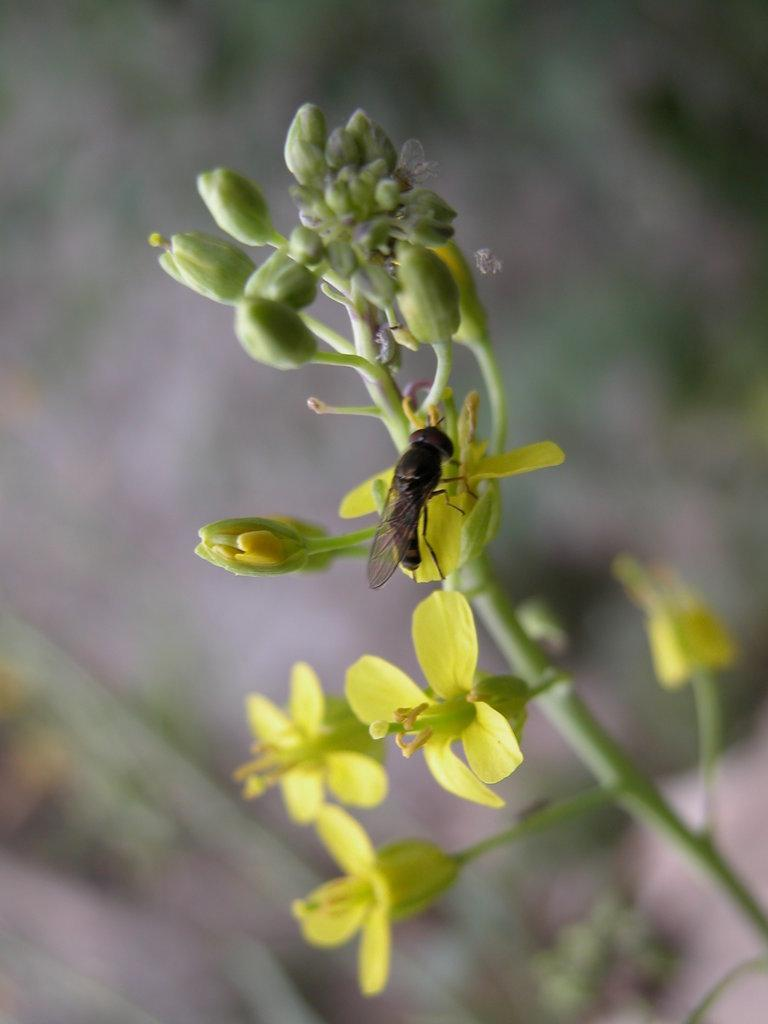What type of flowers can be seen in the image? There are yellow flowers in the image. Is there any wildlife interacting with the flowers? Yes, there is an insect on a yellow flower. What stage of growth are some of the flowers in the image? There are buds on a plant in the image. How would you describe the background of the image? The background of the image is blurry. How many ducks are sitting on the table in the image? There are no ducks or tables present in the image. 